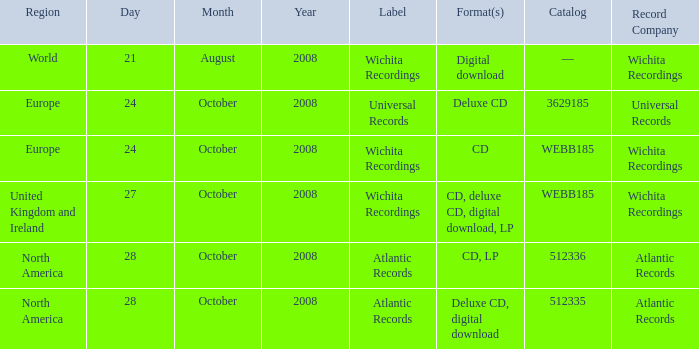Which formats have a region of Europe and Catalog value of WEBB185? CD. 